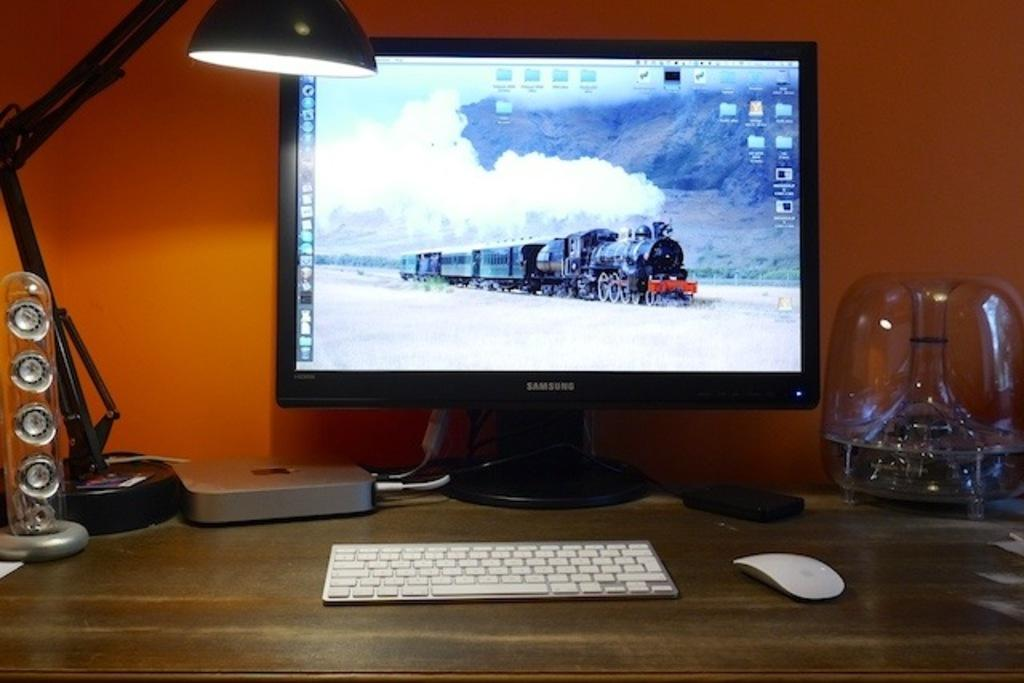Provide a one-sentence caption for the provided image. A Samsung monitor is showing a photo of a steam locomotive. 